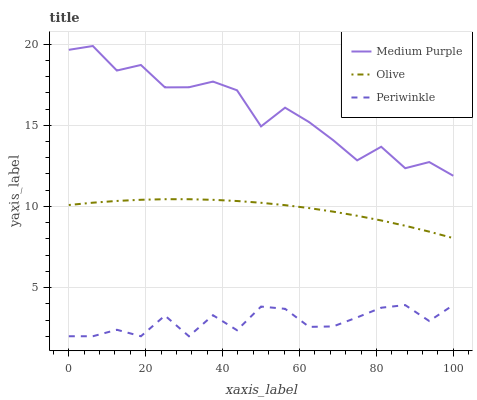Does Periwinkle have the minimum area under the curve?
Answer yes or no. Yes. Does Medium Purple have the maximum area under the curve?
Answer yes or no. Yes. Does Olive have the minimum area under the curve?
Answer yes or no. No. Does Olive have the maximum area under the curve?
Answer yes or no. No. Is Olive the smoothest?
Answer yes or no. Yes. Is Medium Purple the roughest?
Answer yes or no. Yes. Is Periwinkle the smoothest?
Answer yes or no. No. Is Periwinkle the roughest?
Answer yes or no. No. Does Periwinkle have the lowest value?
Answer yes or no. Yes. Does Olive have the lowest value?
Answer yes or no. No. Does Medium Purple have the highest value?
Answer yes or no. Yes. Does Olive have the highest value?
Answer yes or no. No. Is Olive less than Medium Purple?
Answer yes or no. Yes. Is Medium Purple greater than Periwinkle?
Answer yes or no. Yes. Does Olive intersect Medium Purple?
Answer yes or no. No. 